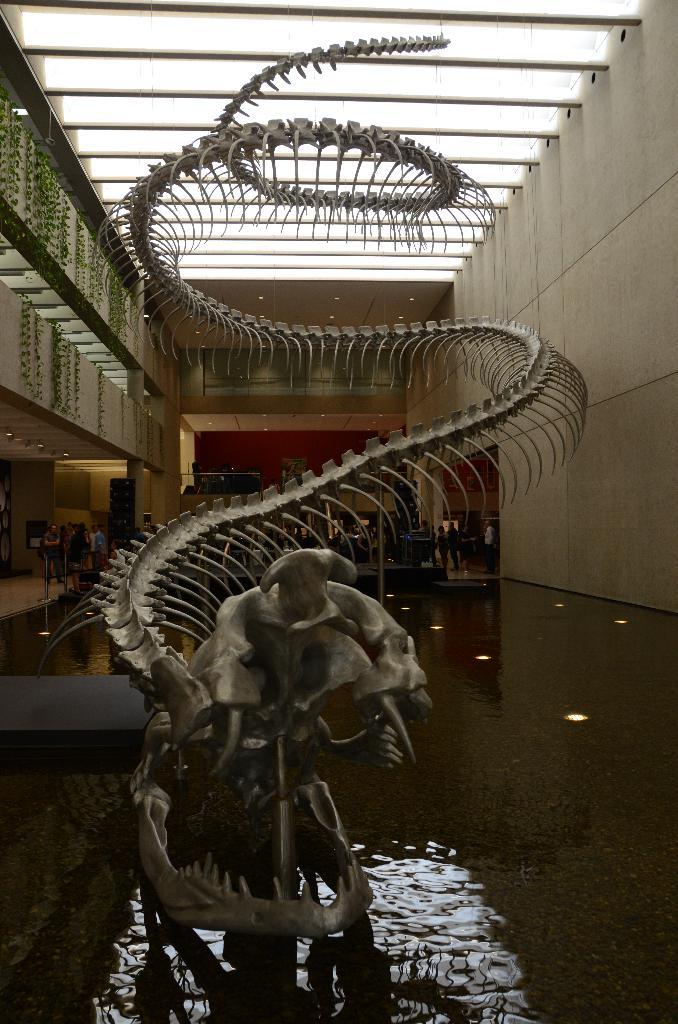What is the main subject in the middle of the image? There is a Dragon skeleton in the middle of the image. What is located at the bottom front side of the image? There is a small water pool in the front bottom side of the image. What is behind the Dragon skeleton? There is a wall behind the Dragon skeleton. What is above the wall? There is a roof above the wall. How many lizards are sitting on the Dragon skeleton in the image? There are no lizards present in the image. What type of ring is being worn by the Dragon skeleton in the image? There is no ring visible on the Dragon skeleton in the image. 